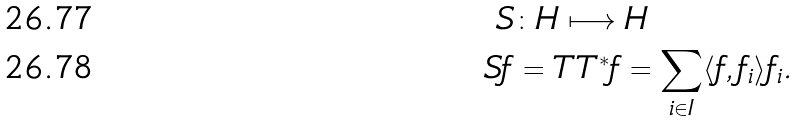<formula> <loc_0><loc_0><loc_500><loc_500>S & \colon H \longmapsto H \\ S f & = T T ^ { * } f = \sum _ { i \in I } \langle f , f _ { i } \rangle f _ { i } .</formula> 